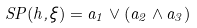Convert formula to latex. <formula><loc_0><loc_0><loc_500><loc_500>S P ( h , \xi ) = a _ { 1 } \vee \left ( { a _ { 2 } \wedge a _ { 3 } } \right )</formula> 